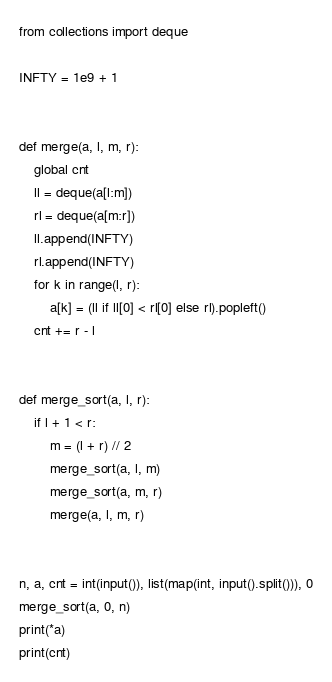<code> <loc_0><loc_0><loc_500><loc_500><_Python_>from collections import deque

INFTY = 1e9 + 1


def merge(a, l, m, r):
    global cnt
    ll = deque(a[l:m])
    rl = deque(a[m:r])
    ll.append(INFTY)
    rl.append(INFTY)
    for k in range(l, r):
        a[k] = (ll if ll[0] < rl[0] else rl).popleft()
    cnt += r - l


def merge_sort(a, l, r):
    if l + 1 < r:
        m = (l + r) // 2
        merge_sort(a, l, m)
        merge_sort(a, m, r)
        merge(a, l, m, r)


n, a, cnt = int(input()), list(map(int, input().split())), 0
merge_sort(a, 0, n)
print(*a)
print(cnt)</code> 